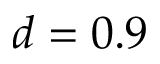<formula> <loc_0><loc_0><loc_500><loc_500>d = 0 . 9</formula> 